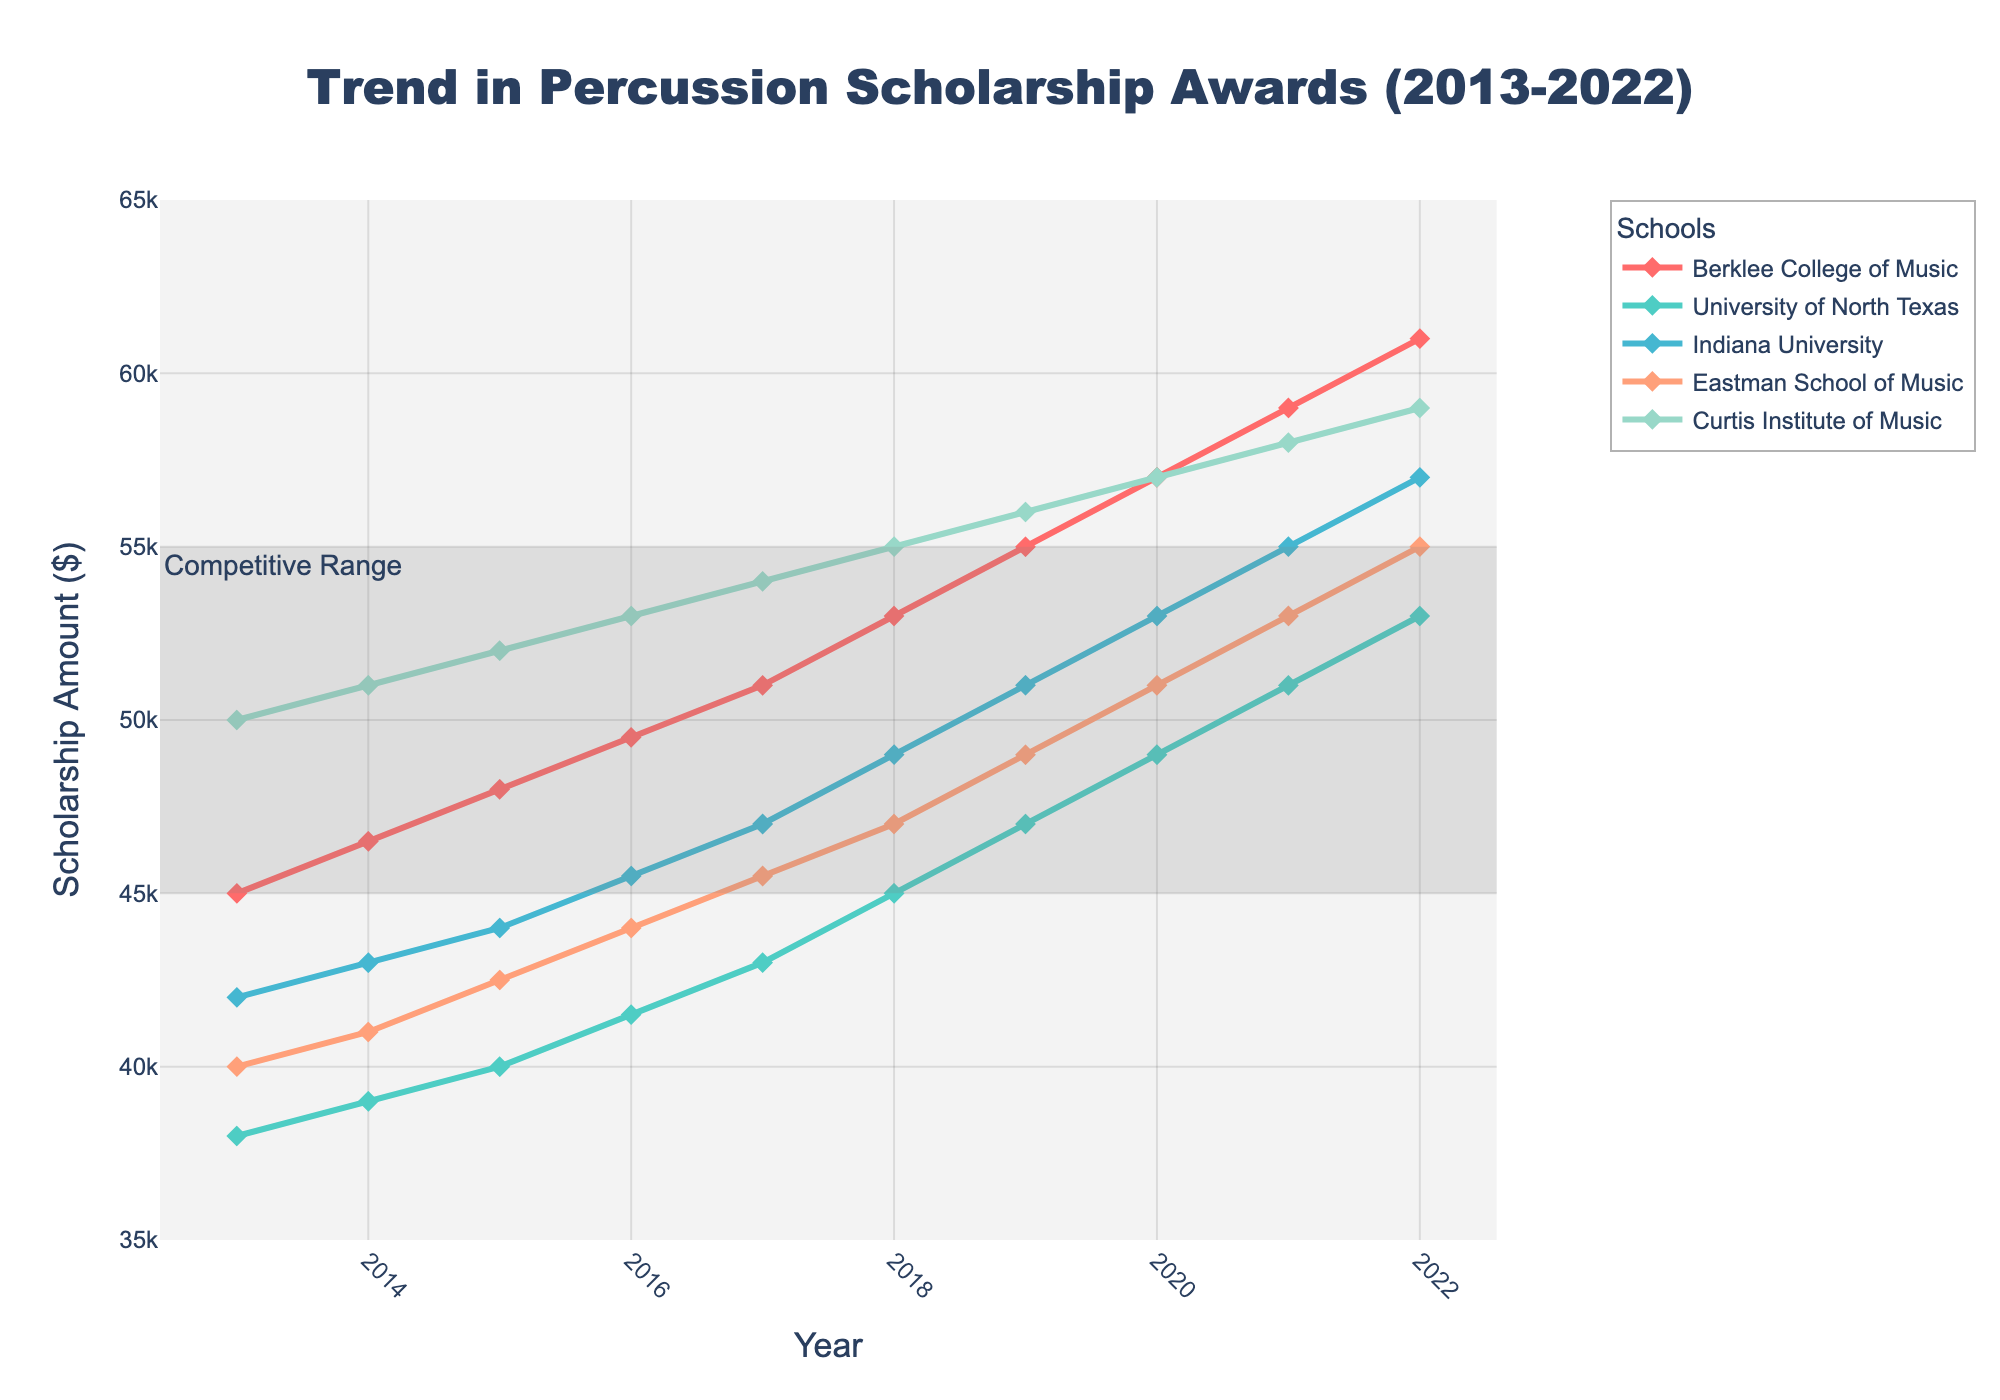Which school had the highest scholarship amount in 2016? Look at the 2016 data points and identify which school has the highest value. The Curtis Institute of Music shows the highest amount, $53,000.
Answer: Curtis Institute of Music Comparing 2014 and 2020, how much did scholarships at Indiana University increase? Subtract the 2014 scholarship amount from the 2020 amount for Indiana University: 53,000 (2020) - 43,000 (2014) = 10,000.
Answer: 10,000 Which school had the smallest increase in scholarship amounts over the decade? Look at the starting (2013) and ending (2022) values for all schools and calculate the difference. The University of North Texas had the smallest increase: 53,000 (2022) - 38,000 (2013) = 15,000.
Answer: University of North Texas What was the average scholarship amount for Berklee College of Music between 2018 and 2022? Calculate the average: (53,000 + 55,000 + 57,000 + 59,000 + 61,000) / 5 = 57,000.
Answer: 57,000 Identify the year when Eastman School of Music scholarships first exceeded $50,000. Track the scholarships for Eastman School of Music through the years and identify the first year over $50,000, which is 2019.
Answer: 2019 For 2021, which school's scholarship amount fell within the highlighted competitive range? Identify scholarships within the range of $45,000 to $55,000 for 2021. Only the University of North Texas and Indiana University show amounts within this range.
Answer: University of North Texas, Indiana University How much more was the scholarship amount for Curtis Institute of Music in 2022 compared to Eastman School of Music in the same year? Subtract Eastman School of Music’s 2022 amount from Curtis Institute of Music’s: 59,000 - 55,000 = 4,000.
Answer: 4,000 Across the decade, which two schools show consistent growth in scholarship amounts annually? Identify schools showing steady increase each year. Both Berklee College of Music and Curtis Institute of Music demonstrate consistent yearly growth.
Answer: Berklee College of Music, Curtis Institute of Music 